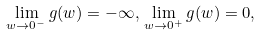<formula> <loc_0><loc_0><loc_500><loc_500>\lim _ { w \to 0 ^ { - } } g ( w ) = - \infty , \, \lim _ { w \to 0 ^ { + } } g ( w ) = 0 ,</formula> 